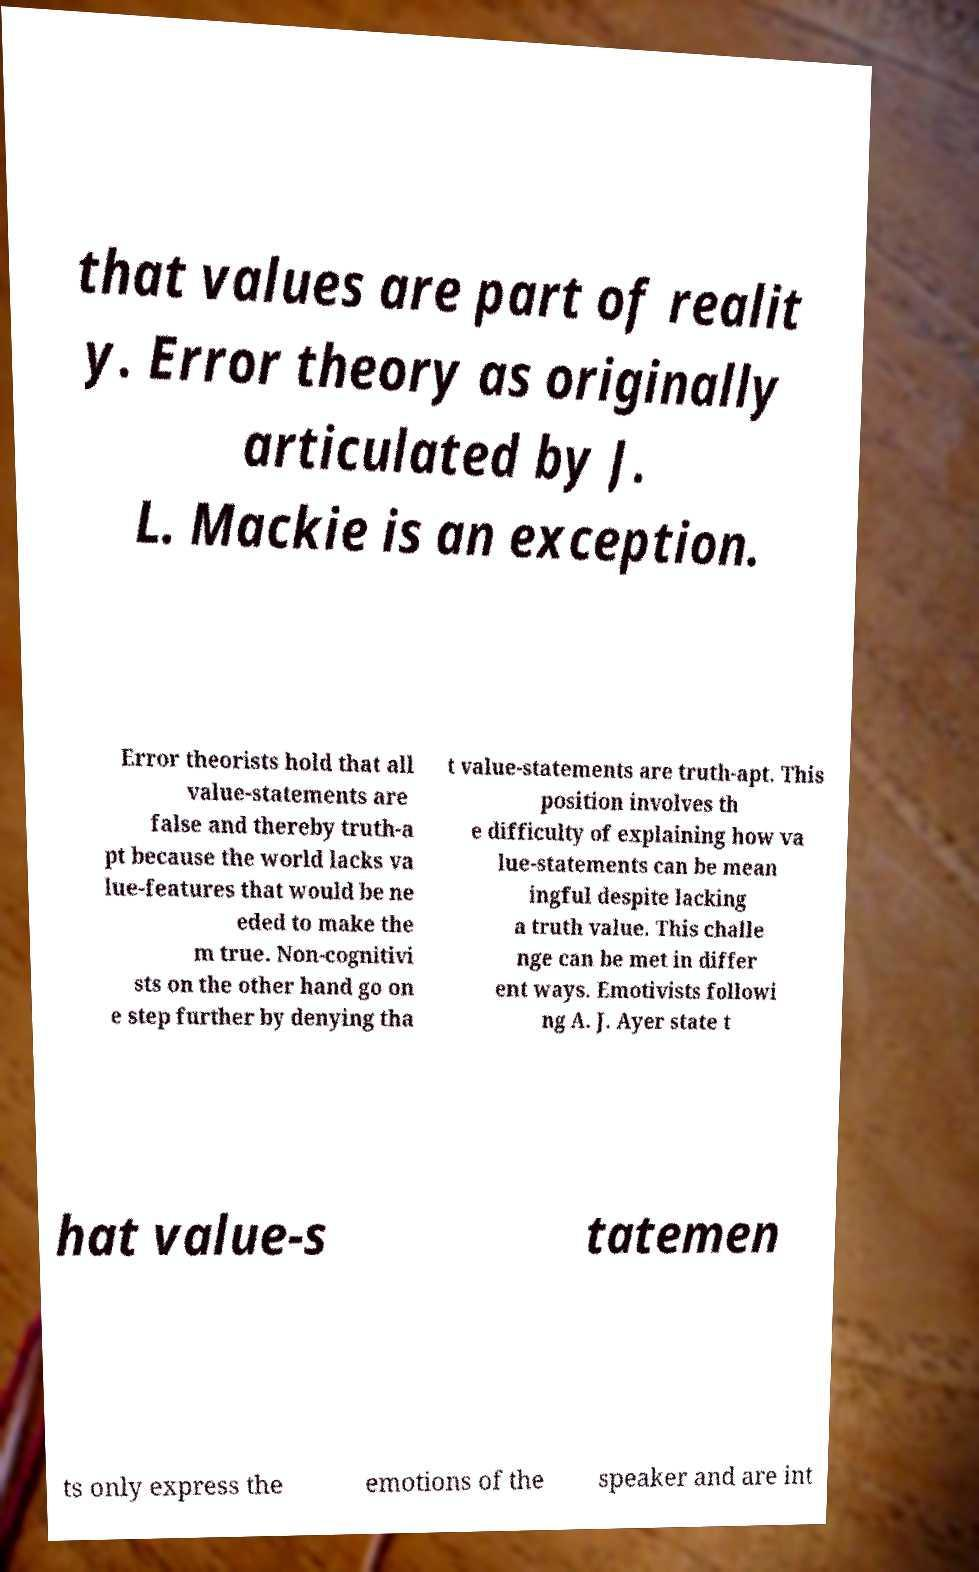For documentation purposes, I need the text within this image transcribed. Could you provide that? that values are part of realit y. Error theory as originally articulated by J. L. Mackie is an exception. Error theorists hold that all value-statements are false and thereby truth-a pt because the world lacks va lue-features that would be ne eded to make the m true. Non-cognitivi sts on the other hand go on e step further by denying tha t value-statements are truth-apt. This position involves th e difficulty of explaining how va lue-statements can be mean ingful despite lacking a truth value. This challe nge can be met in differ ent ways. Emotivists followi ng A. J. Ayer state t hat value-s tatemen ts only express the emotions of the speaker and are int 